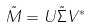Convert formula to latex. <formula><loc_0><loc_0><loc_500><loc_500>\tilde { M } = U \tilde { \Sigma } V ^ { * }</formula> 